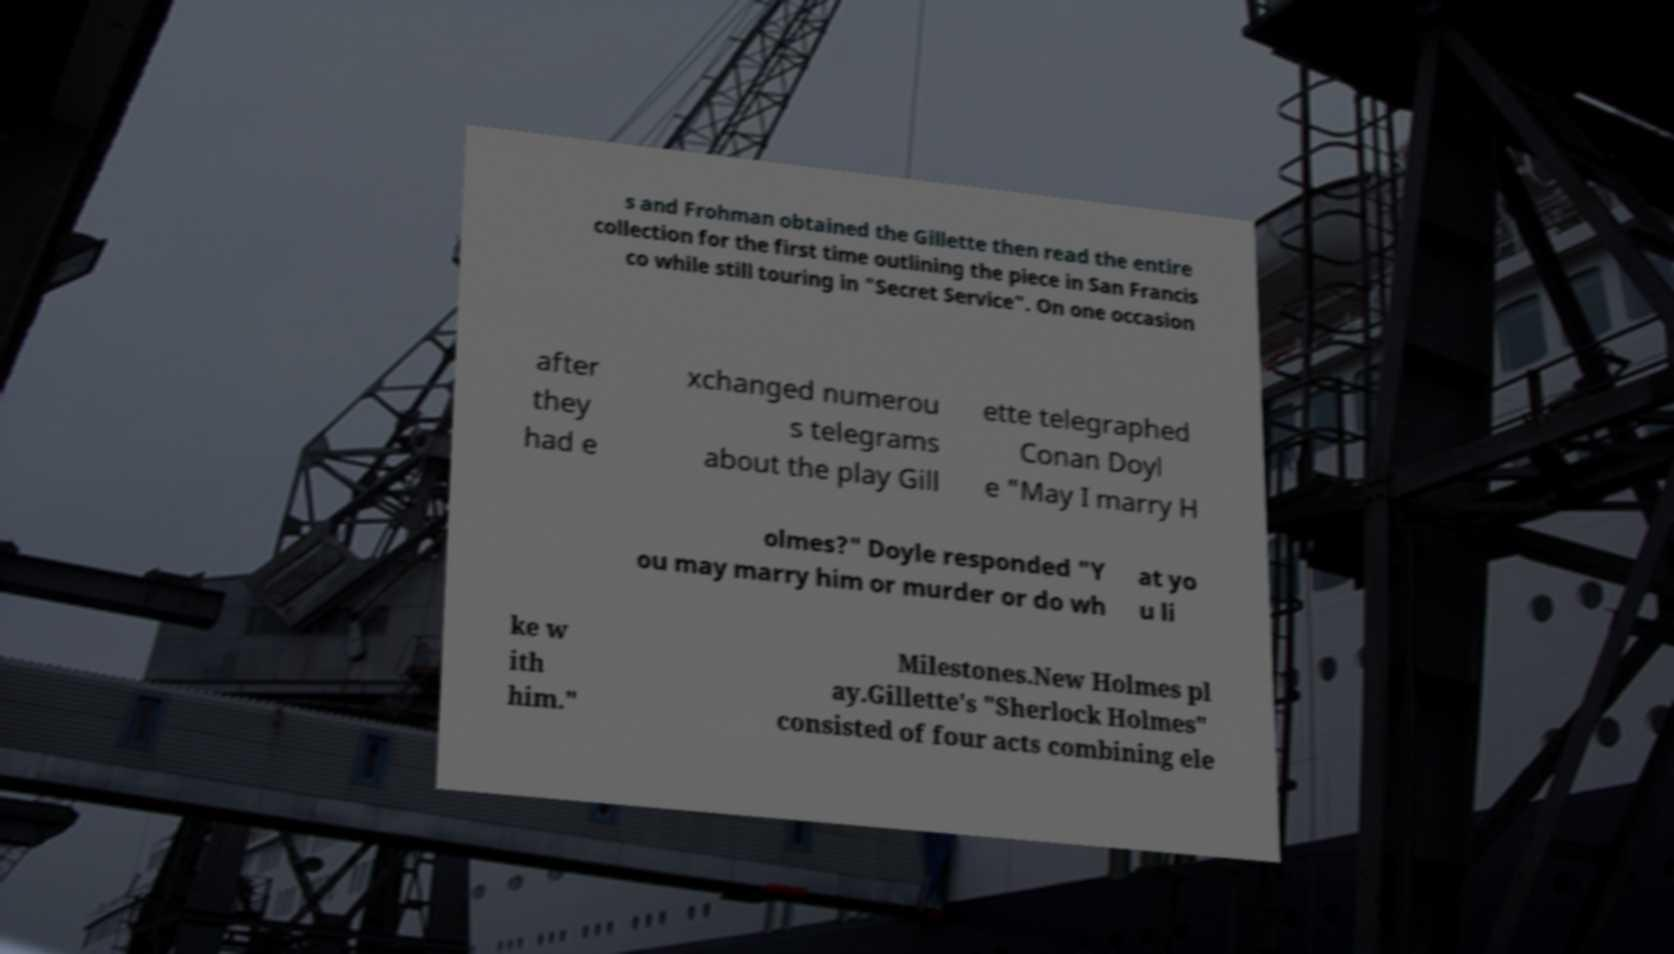Can you read and provide the text displayed in the image?This photo seems to have some interesting text. Can you extract and type it out for me? s and Frohman obtained the Gillette then read the entire collection for the first time outlining the piece in San Francis co while still touring in "Secret Service". On one occasion after they had e xchanged numerou s telegrams about the play Gill ette telegraphed Conan Doyl e "May I marry H olmes?" Doyle responded "Y ou may marry him or murder or do wh at yo u li ke w ith him." Milestones.New Holmes pl ay.Gillette's "Sherlock Holmes" consisted of four acts combining ele 